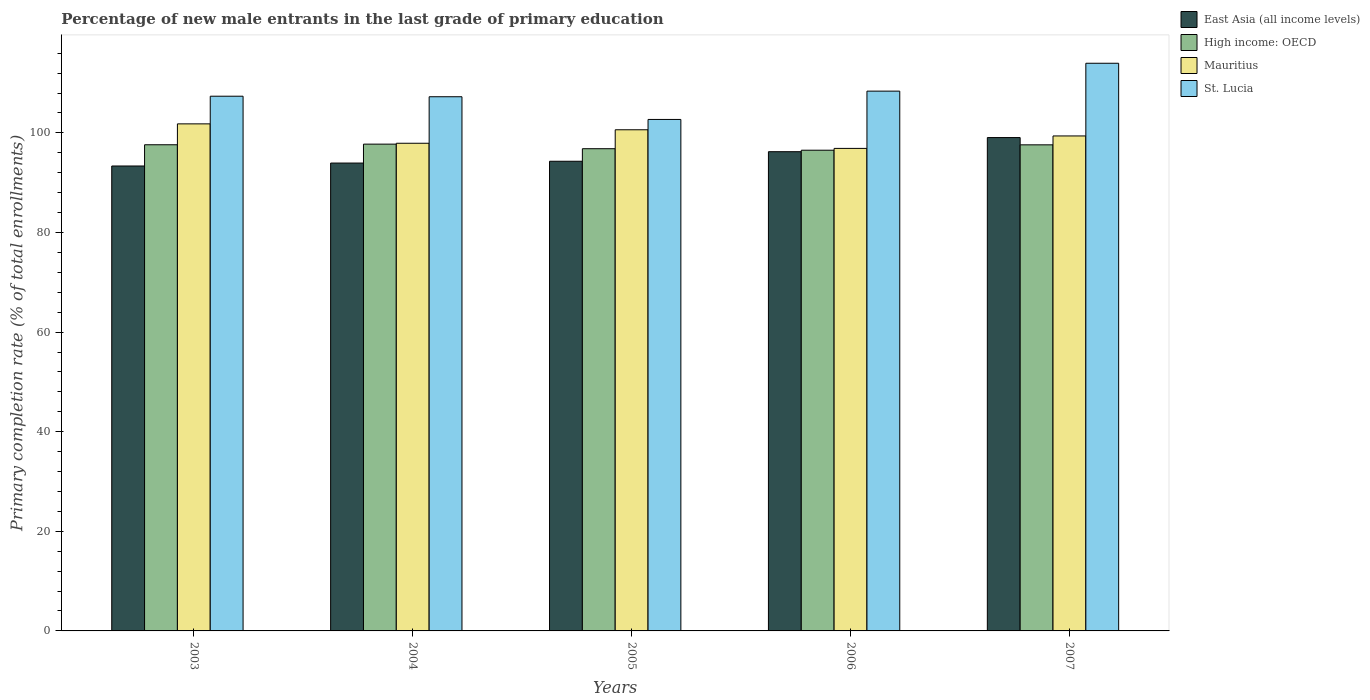How many different coloured bars are there?
Offer a terse response. 4. Are the number of bars per tick equal to the number of legend labels?
Make the answer very short. Yes. How many bars are there on the 5th tick from the left?
Provide a succinct answer. 4. What is the percentage of new male entrants in High income: OECD in 2006?
Your response must be concise. 96.52. Across all years, what is the maximum percentage of new male entrants in St. Lucia?
Give a very brief answer. 113.98. Across all years, what is the minimum percentage of new male entrants in East Asia (all income levels)?
Provide a succinct answer. 93.35. In which year was the percentage of new male entrants in St. Lucia minimum?
Keep it short and to the point. 2005. What is the total percentage of new male entrants in Mauritius in the graph?
Keep it short and to the point. 496.62. What is the difference between the percentage of new male entrants in Mauritius in 2003 and that in 2006?
Offer a terse response. 4.93. What is the difference between the percentage of new male entrants in Mauritius in 2006 and the percentage of new male entrants in High income: OECD in 2004?
Your answer should be very brief. -0.85. What is the average percentage of new male entrants in East Asia (all income levels) per year?
Give a very brief answer. 95.37. In the year 2007, what is the difference between the percentage of new male entrants in Mauritius and percentage of new male entrants in St. Lucia?
Your answer should be compact. -14.59. In how many years, is the percentage of new male entrants in Mauritius greater than 108 %?
Keep it short and to the point. 0. What is the ratio of the percentage of new male entrants in Mauritius in 2005 to that in 2007?
Ensure brevity in your answer.  1.01. Is the difference between the percentage of new male entrants in Mauritius in 2003 and 2007 greater than the difference between the percentage of new male entrants in St. Lucia in 2003 and 2007?
Your response must be concise. Yes. What is the difference between the highest and the second highest percentage of new male entrants in Mauritius?
Ensure brevity in your answer.  1.19. What is the difference between the highest and the lowest percentage of new male entrants in Mauritius?
Provide a succinct answer. 4.93. What does the 3rd bar from the left in 2004 represents?
Make the answer very short. Mauritius. What does the 1st bar from the right in 2003 represents?
Your answer should be compact. St. Lucia. Are all the bars in the graph horizontal?
Ensure brevity in your answer.  No. How many years are there in the graph?
Your response must be concise. 5. What is the difference between two consecutive major ticks on the Y-axis?
Provide a succinct answer. 20. Does the graph contain any zero values?
Give a very brief answer. No. Does the graph contain grids?
Your answer should be very brief. No. How many legend labels are there?
Provide a short and direct response. 4. What is the title of the graph?
Make the answer very short. Percentage of new male entrants in the last grade of primary education. Does "Canada" appear as one of the legend labels in the graph?
Offer a very short reply. No. What is the label or title of the Y-axis?
Offer a very short reply. Primary completion rate (% of total enrollments). What is the Primary completion rate (% of total enrollments) in East Asia (all income levels) in 2003?
Give a very brief answer. 93.35. What is the Primary completion rate (% of total enrollments) of High income: OECD in 2003?
Offer a terse response. 97.62. What is the Primary completion rate (% of total enrollments) in Mauritius in 2003?
Your answer should be very brief. 101.81. What is the Primary completion rate (% of total enrollments) in St. Lucia in 2003?
Make the answer very short. 107.36. What is the Primary completion rate (% of total enrollments) in East Asia (all income levels) in 2004?
Provide a short and direct response. 93.94. What is the Primary completion rate (% of total enrollments) of High income: OECD in 2004?
Provide a short and direct response. 97.74. What is the Primary completion rate (% of total enrollments) in Mauritius in 2004?
Keep it short and to the point. 97.92. What is the Primary completion rate (% of total enrollments) of St. Lucia in 2004?
Keep it short and to the point. 107.26. What is the Primary completion rate (% of total enrollments) of East Asia (all income levels) in 2005?
Provide a succinct answer. 94.3. What is the Primary completion rate (% of total enrollments) of High income: OECD in 2005?
Offer a terse response. 96.82. What is the Primary completion rate (% of total enrollments) in Mauritius in 2005?
Your answer should be compact. 100.62. What is the Primary completion rate (% of total enrollments) in St. Lucia in 2005?
Make the answer very short. 102.7. What is the Primary completion rate (% of total enrollments) of East Asia (all income levels) in 2006?
Your answer should be very brief. 96.22. What is the Primary completion rate (% of total enrollments) of High income: OECD in 2006?
Offer a very short reply. 96.52. What is the Primary completion rate (% of total enrollments) of Mauritius in 2006?
Offer a terse response. 96.88. What is the Primary completion rate (% of total enrollments) in St. Lucia in 2006?
Offer a very short reply. 108.38. What is the Primary completion rate (% of total enrollments) of East Asia (all income levels) in 2007?
Your response must be concise. 99.06. What is the Primary completion rate (% of total enrollments) in High income: OECD in 2007?
Provide a succinct answer. 97.6. What is the Primary completion rate (% of total enrollments) of Mauritius in 2007?
Your answer should be compact. 99.39. What is the Primary completion rate (% of total enrollments) of St. Lucia in 2007?
Give a very brief answer. 113.98. Across all years, what is the maximum Primary completion rate (% of total enrollments) in East Asia (all income levels)?
Your response must be concise. 99.06. Across all years, what is the maximum Primary completion rate (% of total enrollments) in High income: OECD?
Provide a succinct answer. 97.74. Across all years, what is the maximum Primary completion rate (% of total enrollments) of Mauritius?
Offer a very short reply. 101.81. Across all years, what is the maximum Primary completion rate (% of total enrollments) of St. Lucia?
Make the answer very short. 113.98. Across all years, what is the minimum Primary completion rate (% of total enrollments) in East Asia (all income levels)?
Provide a short and direct response. 93.35. Across all years, what is the minimum Primary completion rate (% of total enrollments) in High income: OECD?
Make the answer very short. 96.52. Across all years, what is the minimum Primary completion rate (% of total enrollments) in Mauritius?
Provide a short and direct response. 96.88. Across all years, what is the minimum Primary completion rate (% of total enrollments) in St. Lucia?
Give a very brief answer. 102.7. What is the total Primary completion rate (% of total enrollments) in East Asia (all income levels) in the graph?
Give a very brief answer. 476.87. What is the total Primary completion rate (% of total enrollments) in High income: OECD in the graph?
Offer a terse response. 486.3. What is the total Primary completion rate (% of total enrollments) in Mauritius in the graph?
Provide a succinct answer. 496.62. What is the total Primary completion rate (% of total enrollments) in St. Lucia in the graph?
Provide a succinct answer. 539.68. What is the difference between the Primary completion rate (% of total enrollments) of East Asia (all income levels) in 2003 and that in 2004?
Your answer should be very brief. -0.59. What is the difference between the Primary completion rate (% of total enrollments) in High income: OECD in 2003 and that in 2004?
Your response must be concise. -0.12. What is the difference between the Primary completion rate (% of total enrollments) of Mauritius in 2003 and that in 2004?
Provide a short and direct response. 3.89. What is the difference between the Primary completion rate (% of total enrollments) in St. Lucia in 2003 and that in 2004?
Provide a short and direct response. 0.11. What is the difference between the Primary completion rate (% of total enrollments) in East Asia (all income levels) in 2003 and that in 2005?
Offer a terse response. -0.95. What is the difference between the Primary completion rate (% of total enrollments) of High income: OECD in 2003 and that in 2005?
Offer a terse response. 0.79. What is the difference between the Primary completion rate (% of total enrollments) in Mauritius in 2003 and that in 2005?
Provide a succinct answer. 1.19. What is the difference between the Primary completion rate (% of total enrollments) of St. Lucia in 2003 and that in 2005?
Keep it short and to the point. 4.66. What is the difference between the Primary completion rate (% of total enrollments) in East Asia (all income levels) in 2003 and that in 2006?
Keep it short and to the point. -2.87. What is the difference between the Primary completion rate (% of total enrollments) of High income: OECD in 2003 and that in 2006?
Offer a very short reply. 1.09. What is the difference between the Primary completion rate (% of total enrollments) of Mauritius in 2003 and that in 2006?
Provide a short and direct response. 4.93. What is the difference between the Primary completion rate (% of total enrollments) of St. Lucia in 2003 and that in 2006?
Offer a very short reply. -1.02. What is the difference between the Primary completion rate (% of total enrollments) in East Asia (all income levels) in 2003 and that in 2007?
Your answer should be compact. -5.71. What is the difference between the Primary completion rate (% of total enrollments) in High income: OECD in 2003 and that in 2007?
Offer a very short reply. 0.02. What is the difference between the Primary completion rate (% of total enrollments) in Mauritius in 2003 and that in 2007?
Your answer should be very brief. 2.42. What is the difference between the Primary completion rate (% of total enrollments) in St. Lucia in 2003 and that in 2007?
Keep it short and to the point. -6.62. What is the difference between the Primary completion rate (% of total enrollments) in East Asia (all income levels) in 2004 and that in 2005?
Give a very brief answer. -0.36. What is the difference between the Primary completion rate (% of total enrollments) of High income: OECD in 2004 and that in 2005?
Your answer should be very brief. 0.92. What is the difference between the Primary completion rate (% of total enrollments) of Mauritius in 2004 and that in 2005?
Offer a terse response. -2.71. What is the difference between the Primary completion rate (% of total enrollments) in St. Lucia in 2004 and that in 2005?
Keep it short and to the point. 4.56. What is the difference between the Primary completion rate (% of total enrollments) of East Asia (all income levels) in 2004 and that in 2006?
Provide a succinct answer. -2.28. What is the difference between the Primary completion rate (% of total enrollments) in High income: OECD in 2004 and that in 2006?
Your answer should be compact. 1.22. What is the difference between the Primary completion rate (% of total enrollments) in Mauritius in 2004 and that in 2006?
Provide a short and direct response. 1.03. What is the difference between the Primary completion rate (% of total enrollments) of St. Lucia in 2004 and that in 2006?
Keep it short and to the point. -1.12. What is the difference between the Primary completion rate (% of total enrollments) of East Asia (all income levels) in 2004 and that in 2007?
Your answer should be compact. -5.12. What is the difference between the Primary completion rate (% of total enrollments) in High income: OECD in 2004 and that in 2007?
Offer a very short reply. 0.14. What is the difference between the Primary completion rate (% of total enrollments) in Mauritius in 2004 and that in 2007?
Offer a very short reply. -1.47. What is the difference between the Primary completion rate (% of total enrollments) in St. Lucia in 2004 and that in 2007?
Ensure brevity in your answer.  -6.72. What is the difference between the Primary completion rate (% of total enrollments) in East Asia (all income levels) in 2005 and that in 2006?
Your answer should be very brief. -1.92. What is the difference between the Primary completion rate (% of total enrollments) in High income: OECD in 2005 and that in 2006?
Offer a very short reply. 0.3. What is the difference between the Primary completion rate (% of total enrollments) in Mauritius in 2005 and that in 2006?
Your answer should be compact. 3.74. What is the difference between the Primary completion rate (% of total enrollments) in St. Lucia in 2005 and that in 2006?
Your response must be concise. -5.68. What is the difference between the Primary completion rate (% of total enrollments) of East Asia (all income levels) in 2005 and that in 2007?
Your answer should be very brief. -4.76. What is the difference between the Primary completion rate (% of total enrollments) in High income: OECD in 2005 and that in 2007?
Your answer should be very brief. -0.78. What is the difference between the Primary completion rate (% of total enrollments) of Mauritius in 2005 and that in 2007?
Provide a short and direct response. 1.24. What is the difference between the Primary completion rate (% of total enrollments) in St. Lucia in 2005 and that in 2007?
Provide a short and direct response. -11.28. What is the difference between the Primary completion rate (% of total enrollments) of East Asia (all income levels) in 2006 and that in 2007?
Ensure brevity in your answer.  -2.84. What is the difference between the Primary completion rate (% of total enrollments) in High income: OECD in 2006 and that in 2007?
Make the answer very short. -1.08. What is the difference between the Primary completion rate (% of total enrollments) in Mauritius in 2006 and that in 2007?
Your answer should be very brief. -2.5. What is the difference between the Primary completion rate (% of total enrollments) of St. Lucia in 2006 and that in 2007?
Make the answer very short. -5.6. What is the difference between the Primary completion rate (% of total enrollments) of East Asia (all income levels) in 2003 and the Primary completion rate (% of total enrollments) of High income: OECD in 2004?
Your answer should be compact. -4.39. What is the difference between the Primary completion rate (% of total enrollments) of East Asia (all income levels) in 2003 and the Primary completion rate (% of total enrollments) of Mauritius in 2004?
Offer a very short reply. -4.56. What is the difference between the Primary completion rate (% of total enrollments) in East Asia (all income levels) in 2003 and the Primary completion rate (% of total enrollments) in St. Lucia in 2004?
Your response must be concise. -13.91. What is the difference between the Primary completion rate (% of total enrollments) of High income: OECD in 2003 and the Primary completion rate (% of total enrollments) of Mauritius in 2004?
Your answer should be compact. -0.3. What is the difference between the Primary completion rate (% of total enrollments) in High income: OECD in 2003 and the Primary completion rate (% of total enrollments) in St. Lucia in 2004?
Provide a short and direct response. -9.64. What is the difference between the Primary completion rate (% of total enrollments) in Mauritius in 2003 and the Primary completion rate (% of total enrollments) in St. Lucia in 2004?
Offer a terse response. -5.45. What is the difference between the Primary completion rate (% of total enrollments) in East Asia (all income levels) in 2003 and the Primary completion rate (% of total enrollments) in High income: OECD in 2005?
Give a very brief answer. -3.47. What is the difference between the Primary completion rate (% of total enrollments) of East Asia (all income levels) in 2003 and the Primary completion rate (% of total enrollments) of Mauritius in 2005?
Offer a terse response. -7.27. What is the difference between the Primary completion rate (% of total enrollments) of East Asia (all income levels) in 2003 and the Primary completion rate (% of total enrollments) of St. Lucia in 2005?
Offer a terse response. -9.35. What is the difference between the Primary completion rate (% of total enrollments) in High income: OECD in 2003 and the Primary completion rate (% of total enrollments) in Mauritius in 2005?
Keep it short and to the point. -3.01. What is the difference between the Primary completion rate (% of total enrollments) in High income: OECD in 2003 and the Primary completion rate (% of total enrollments) in St. Lucia in 2005?
Your response must be concise. -5.08. What is the difference between the Primary completion rate (% of total enrollments) in Mauritius in 2003 and the Primary completion rate (% of total enrollments) in St. Lucia in 2005?
Offer a terse response. -0.89. What is the difference between the Primary completion rate (% of total enrollments) of East Asia (all income levels) in 2003 and the Primary completion rate (% of total enrollments) of High income: OECD in 2006?
Your response must be concise. -3.17. What is the difference between the Primary completion rate (% of total enrollments) in East Asia (all income levels) in 2003 and the Primary completion rate (% of total enrollments) in Mauritius in 2006?
Provide a short and direct response. -3.53. What is the difference between the Primary completion rate (% of total enrollments) in East Asia (all income levels) in 2003 and the Primary completion rate (% of total enrollments) in St. Lucia in 2006?
Your answer should be very brief. -15.03. What is the difference between the Primary completion rate (% of total enrollments) in High income: OECD in 2003 and the Primary completion rate (% of total enrollments) in Mauritius in 2006?
Provide a short and direct response. 0.73. What is the difference between the Primary completion rate (% of total enrollments) in High income: OECD in 2003 and the Primary completion rate (% of total enrollments) in St. Lucia in 2006?
Keep it short and to the point. -10.77. What is the difference between the Primary completion rate (% of total enrollments) in Mauritius in 2003 and the Primary completion rate (% of total enrollments) in St. Lucia in 2006?
Ensure brevity in your answer.  -6.57. What is the difference between the Primary completion rate (% of total enrollments) of East Asia (all income levels) in 2003 and the Primary completion rate (% of total enrollments) of High income: OECD in 2007?
Your answer should be compact. -4.25. What is the difference between the Primary completion rate (% of total enrollments) of East Asia (all income levels) in 2003 and the Primary completion rate (% of total enrollments) of Mauritius in 2007?
Your response must be concise. -6.03. What is the difference between the Primary completion rate (% of total enrollments) of East Asia (all income levels) in 2003 and the Primary completion rate (% of total enrollments) of St. Lucia in 2007?
Your answer should be very brief. -20.63. What is the difference between the Primary completion rate (% of total enrollments) of High income: OECD in 2003 and the Primary completion rate (% of total enrollments) of Mauritius in 2007?
Provide a short and direct response. -1.77. What is the difference between the Primary completion rate (% of total enrollments) in High income: OECD in 2003 and the Primary completion rate (% of total enrollments) in St. Lucia in 2007?
Provide a succinct answer. -16.36. What is the difference between the Primary completion rate (% of total enrollments) in Mauritius in 2003 and the Primary completion rate (% of total enrollments) in St. Lucia in 2007?
Your answer should be compact. -12.17. What is the difference between the Primary completion rate (% of total enrollments) of East Asia (all income levels) in 2004 and the Primary completion rate (% of total enrollments) of High income: OECD in 2005?
Give a very brief answer. -2.88. What is the difference between the Primary completion rate (% of total enrollments) of East Asia (all income levels) in 2004 and the Primary completion rate (% of total enrollments) of Mauritius in 2005?
Give a very brief answer. -6.68. What is the difference between the Primary completion rate (% of total enrollments) in East Asia (all income levels) in 2004 and the Primary completion rate (% of total enrollments) in St. Lucia in 2005?
Keep it short and to the point. -8.76. What is the difference between the Primary completion rate (% of total enrollments) of High income: OECD in 2004 and the Primary completion rate (% of total enrollments) of Mauritius in 2005?
Your answer should be very brief. -2.88. What is the difference between the Primary completion rate (% of total enrollments) of High income: OECD in 2004 and the Primary completion rate (% of total enrollments) of St. Lucia in 2005?
Your answer should be very brief. -4.96. What is the difference between the Primary completion rate (% of total enrollments) in Mauritius in 2004 and the Primary completion rate (% of total enrollments) in St. Lucia in 2005?
Give a very brief answer. -4.78. What is the difference between the Primary completion rate (% of total enrollments) of East Asia (all income levels) in 2004 and the Primary completion rate (% of total enrollments) of High income: OECD in 2006?
Offer a terse response. -2.58. What is the difference between the Primary completion rate (% of total enrollments) in East Asia (all income levels) in 2004 and the Primary completion rate (% of total enrollments) in Mauritius in 2006?
Your response must be concise. -2.94. What is the difference between the Primary completion rate (% of total enrollments) in East Asia (all income levels) in 2004 and the Primary completion rate (% of total enrollments) in St. Lucia in 2006?
Offer a terse response. -14.44. What is the difference between the Primary completion rate (% of total enrollments) in High income: OECD in 2004 and the Primary completion rate (% of total enrollments) in Mauritius in 2006?
Give a very brief answer. 0.85. What is the difference between the Primary completion rate (% of total enrollments) of High income: OECD in 2004 and the Primary completion rate (% of total enrollments) of St. Lucia in 2006?
Offer a terse response. -10.64. What is the difference between the Primary completion rate (% of total enrollments) in Mauritius in 2004 and the Primary completion rate (% of total enrollments) in St. Lucia in 2006?
Keep it short and to the point. -10.47. What is the difference between the Primary completion rate (% of total enrollments) in East Asia (all income levels) in 2004 and the Primary completion rate (% of total enrollments) in High income: OECD in 2007?
Offer a terse response. -3.66. What is the difference between the Primary completion rate (% of total enrollments) in East Asia (all income levels) in 2004 and the Primary completion rate (% of total enrollments) in Mauritius in 2007?
Your answer should be compact. -5.45. What is the difference between the Primary completion rate (% of total enrollments) of East Asia (all income levels) in 2004 and the Primary completion rate (% of total enrollments) of St. Lucia in 2007?
Your answer should be compact. -20.04. What is the difference between the Primary completion rate (% of total enrollments) of High income: OECD in 2004 and the Primary completion rate (% of total enrollments) of Mauritius in 2007?
Your answer should be compact. -1.65. What is the difference between the Primary completion rate (% of total enrollments) in High income: OECD in 2004 and the Primary completion rate (% of total enrollments) in St. Lucia in 2007?
Offer a terse response. -16.24. What is the difference between the Primary completion rate (% of total enrollments) in Mauritius in 2004 and the Primary completion rate (% of total enrollments) in St. Lucia in 2007?
Ensure brevity in your answer.  -16.06. What is the difference between the Primary completion rate (% of total enrollments) in East Asia (all income levels) in 2005 and the Primary completion rate (% of total enrollments) in High income: OECD in 2006?
Provide a succinct answer. -2.22. What is the difference between the Primary completion rate (% of total enrollments) in East Asia (all income levels) in 2005 and the Primary completion rate (% of total enrollments) in Mauritius in 2006?
Provide a short and direct response. -2.58. What is the difference between the Primary completion rate (% of total enrollments) of East Asia (all income levels) in 2005 and the Primary completion rate (% of total enrollments) of St. Lucia in 2006?
Provide a short and direct response. -14.08. What is the difference between the Primary completion rate (% of total enrollments) of High income: OECD in 2005 and the Primary completion rate (% of total enrollments) of Mauritius in 2006?
Your answer should be very brief. -0.06. What is the difference between the Primary completion rate (% of total enrollments) of High income: OECD in 2005 and the Primary completion rate (% of total enrollments) of St. Lucia in 2006?
Your response must be concise. -11.56. What is the difference between the Primary completion rate (% of total enrollments) of Mauritius in 2005 and the Primary completion rate (% of total enrollments) of St. Lucia in 2006?
Give a very brief answer. -7.76. What is the difference between the Primary completion rate (% of total enrollments) of East Asia (all income levels) in 2005 and the Primary completion rate (% of total enrollments) of High income: OECD in 2007?
Offer a terse response. -3.3. What is the difference between the Primary completion rate (% of total enrollments) of East Asia (all income levels) in 2005 and the Primary completion rate (% of total enrollments) of Mauritius in 2007?
Your response must be concise. -5.08. What is the difference between the Primary completion rate (% of total enrollments) in East Asia (all income levels) in 2005 and the Primary completion rate (% of total enrollments) in St. Lucia in 2007?
Give a very brief answer. -19.68. What is the difference between the Primary completion rate (% of total enrollments) in High income: OECD in 2005 and the Primary completion rate (% of total enrollments) in Mauritius in 2007?
Your answer should be very brief. -2.56. What is the difference between the Primary completion rate (% of total enrollments) of High income: OECD in 2005 and the Primary completion rate (% of total enrollments) of St. Lucia in 2007?
Keep it short and to the point. -17.16. What is the difference between the Primary completion rate (% of total enrollments) in Mauritius in 2005 and the Primary completion rate (% of total enrollments) in St. Lucia in 2007?
Give a very brief answer. -13.36. What is the difference between the Primary completion rate (% of total enrollments) in East Asia (all income levels) in 2006 and the Primary completion rate (% of total enrollments) in High income: OECD in 2007?
Your answer should be compact. -1.38. What is the difference between the Primary completion rate (% of total enrollments) of East Asia (all income levels) in 2006 and the Primary completion rate (% of total enrollments) of Mauritius in 2007?
Your answer should be compact. -3.16. What is the difference between the Primary completion rate (% of total enrollments) in East Asia (all income levels) in 2006 and the Primary completion rate (% of total enrollments) in St. Lucia in 2007?
Make the answer very short. -17.76. What is the difference between the Primary completion rate (% of total enrollments) in High income: OECD in 2006 and the Primary completion rate (% of total enrollments) in Mauritius in 2007?
Keep it short and to the point. -2.86. What is the difference between the Primary completion rate (% of total enrollments) of High income: OECD in 2006 and the Primary completion rate (% of total enrollments) of St. Lucia in 2007?
Your answer should be compact. -17.46. What is the difference between the Primary completion rate (% of total enrollments) in Mauritius in 2006 and the Primary completion rate (% of total enrollments) in St. Lucia in 2007?
Give a very brief answer. -17.09. What is the average Primary completion rate (% of total enrollments) of East Asia (all income levels) per year?
Keep it short and to the point. 95.37. What is the average Primary completion rate (% of total enrollments) of High income: OECD per year?
Make the answer very short. 97.26. What is the average Primary completion rate (% of total enrollments) in Mauritius per year?
Offer a terse response. 99.32. What is the average Primary completion rate (% of total enrollments) of St. Lucia per year?
Your answer should be very brief. 107.94. In the year 2003, what is the difference between the Primary completion rate (% of total enrollments) in East Asia (all income levels) and Primary completion rate (% of total enrollments) in High income: OECD?
Your response must be concise. -4.26. In the year 2003, what is the difference between the Primary completion rate (% of total enrollments) of East Asia (all income levels) and Primary completion rate (% of total enrollments) of Mauritius?
Provide a short and direct response. -8.46. In the year 2003, what is the difference between the Primary completion rate (% of total enrollments) in East Asia (all income levels) and Primary completion rate (% of total enrollments) in St. Lucia?
Give a very brief answer. -14.01. In the year 2003, what is the difference between the Primary completion rate (% of total enrollments) of High income: OECD and Primary completion rate (% of total enrollments) of Mauritius?
Your answer should be compact. -4.19. In the year 2003, what is the difference between the Primary completion rate (% of total enrollments) of High income: OECD and Primary completion rate (% of total enrollments) of St. Lucia?
Your response must be concise. -9.75. In the year 2003, what is the difference between the Primary completion rate (% of total enrollments) in Mauritius and Primary completion rate (% of total enrollments) in St. Lucia?
Provide a short and direct response. -5.55. In the year 2004, what is the difference between the Primary completion rate (% of total enrollments) of East Asia (all income levels) and Primary completion rate (% of total enrollments) of High income: OECD?
Offer a terse response. -3.8. In the year 2004, what is the difference between the Primary completion rate (% of total enrollments) of East Asia (all income levels) and Primary completion rate (% of total enrollments) of Mauritius?
Keep it short and to the point. -3.97. In the year 2004, what is the difference between the Primary completion rate (% of total enrollments) in East Asia (all income levels) and Primary completion rate (% of total enrollments) in St. Lucia?
Your answer should be very brief. -13.32. In the year 2004, what is the difference between the Primary completion rate (% of total enrollments) of High income: OECD and Primary completion rate (% of total enrollments) of Mauritius?
Keep it short and to the point. -0.18. In the year 2004, what is the difference between the Primary completion rate (% of total enrollments) of High income: OECD and Primary completion rate (% of total enrollments) of St. Lucia?
Your answer should be very brief. -9.52. In the year 2004, what is the difference between the Primary completion rate (% of total enrollments) of Mauritius and Primary completion rate (% of total enrollments) of St. Lucia?
Keep it short and to the point. -9.34. In the year 2005, what is the difference between the Primary completion rate (% of total enrollments) of East Asia (all income levels) and Primary completion rate (% of total enrollments) of High income: OECD?
Provide a short and direct response. -2.52. In the year 2005, what is the difference between the Primary completion rate (% of total enrollments) in East Asia (all income levels) and Primary completion rate (% of total enrollments) in Mauritius?
Offer a terse response. -6.32. In the year 2005, what is the difference between the Primary completion rate (% of total enrollments) in East Asia (all income levels) and Primary completion rate (% of total enrollments) in St. Lucia?
Keep it short and to the point. -8.4. In the year 2005, what is the difference between the Primary completion rate (% of total enrollments) in High income: OECD and Primary completion rate (% of total enrollments) in Mauritius?
Your answer should be compact. -3.8. In the year 2005, what is the difference between the Primary completion rate (% of total enrollments) in High income: OECD and Primary completion rate (% of total enrollments) in St. Lucia?
Ensure brevity in your answer.  -5.88. In the year 2005, what is the difference between the Primary completion rate (% of total enrollments) of Mauritius and Primary completion rate (% of total enrollments) of St. Lucia?
Ensure brevity in your answer.  -2.08. In the year 2006, what is the difference between the Primary completion rate (% of total enrollments) of East Asia (all income levels) and Primary completion rate (% of total enrollments) of High income: OECD?
Your answer should be very brief. -0.3. In the year 2006, what is the difference between the Primary completion rate (% of total enrollments) of East Asia (all income levels) and Primary completion rate (% of total enrollments) of Mauritius?
Make the answer very short. -0.66. In the year 2006, what is the difference between the Primary completion rate (% of total enrollments) in East Asia (all income levels) and Primary completion rate (% of total enrollments) in St. Lucia?
Offer a very short reply. -12.16. In the year 2006, what is the difference between the Primary completion rate (% of total enrollments) in High income: OECD and Primary completion rate (% of total enrollments) in Mauritius?
Keep it short and to the point. -0.36. In the year 2006, what is the difference between the Primary completion rate (% of total enrollments) in High income: OECD and Primary completion rate (% of total enrollments) in St. Lucia?
Keep it short and to the point. -11.86. In the year 2006, what is the difference between the Primary completion rate (% of total enrollments) in Mauritius and Primary completion rate (% of total enrollments) in St. Lucia?
Offer a very short reply. -11.5. In the year 2007, what is the difference between the Primary completion rate (% of total enrollments) of East Asia (all income levels) and Primary completion rate (% of total enrollments) of High income: OECD?
Offer a very short reply. 1.46. In the year 2007, what is the difference between the Primary completion rate (% of total enrollments) of East Asia (all income levels) and Primary completion rate (% of total enrollments) of Mauritius?
Offer a very short reply. -0.33. In the year 2007, what is the difference between the Primary completion rate (% of total enrollments) in East Asia (all income levels) and Primary completion rate (% of total enrollments) in St. Lucia?
Ensure brevity in your answer.  -14.92. In the year 2007, what is the difference between the Primary completion rate (% of total enrollments) in High income: OECD and Primary completion rate (% of total enrollments) in Mauritius?
Your response must be concise. -1.79. In the year 2007, what is the difference between the Primary completion rate (% of total enrollments) of High income: OECD and Primary completion rate (% of total enrollments) of St. Lucia?
Keep it short and to the point. -16.38. In the year 2007, what is the difference between the Primary completion rate (% of total enrollments) of Mauritius and Primary completion rate (% of total enrollments) of St. Lucia?
Your answer should be very brief. -14.59. What is the ratio of the Primary completion rate (% of total enrollments) in East Asia (all income levels) in 2003 to that in 2004?
Ensure brevity in your answer.  0.99. What is the ratio of the Primary completion rate (% of total enrollments) in Mauritius in 2003 to that in 2004?
Offer a terse response. 1.04. What is the ratio of the Primary completion rate (% of total enrollments) in St. Lucia in 2003 to that in 2004?
Provide a short and direct response. 1. What is the ratio of the Primary completion rate (% of total enrollments) in East Asia (all income levels) in 2003 to that in 2005?
Offer a terse response. 0.99. What is the ratio of the Primary completion rate (% of total enrollments) of High income: OECD in 2003 to that in 2005?
Make the answer very short. 1.01. What is the ratio of the Primary completion rate (% of total enrollments) of Mauritius in 2003 to that in 2005?
Provide a succinct answer. 1.01. What is the ratio of the Primary completion rate (% of total enrollments) of St. Lucia in 2003 to that in 2005?
Make the answer very short. 1.05. What is the ratio of the Primary completion rate (% of total enrollments) of East Asia (all income levels) in 2003 to that in 2006?
Provide a short and direct response. 0.97. What is the ratio of the Primary completion rate (% of total enrollments) of High income: OECD in 2003 to that in 2006?
Make the answer very short. 1.01. What is the ratio of the Primary completion rate (% of total enrollments) in Mauritius in 2003 to that in 2006?
Keep it short and to the point. 1.05. What is the ratio of the Primary completion rate (% of total enrollments) in St. Lucia in 2003 to that in 2006?
Offer a very short reply. 0.99. What is the ratio of the Primary completion rate (% of total enrollments) of East Asia (all income levels) in 2003 to that in 2007?
Offer a very short reply. 0.94. What is the ratio of the Primary completion rate (% of total enrollments) of High income: OECD in 2003 to that in 2007?
Offer a very short reply. 1. What is the ratio of the Primary completion rate (% of total enrollments) of Mauritius in 2003 to that in 2007?
Your answer should be compact. 1.02. What is the ratio of the Primary completion rate (% of total enrollments) of St. Lucia in 2003 to that in 2007?
Provide a short and direct response. 0.94. What is the ratio of the Primary completion rate (% of total enrollments) of East Asia (all income levels) in 2004 to that in 2005?
Give a very brief answer. 1. What is the ratio of the Primary completion rate (% of total enrollments) of High income: OECD in 2004 to that in 2005?
Ensure brevity in your answer.  1.01. What is the ratio of the Primary completion rate (% of total enrollments) of Mauritius in 2004 to that in 2005?
Make the answer very short. 0.97. What is the ratio of the Primary completion rate (% of total enrollments) of St. Lucia in 2004 to that in 2005?
Offer a terse response. 1.04. What is the ratio of the Primary completion rate (% of total enrollments) of East Asia (all income levels) in 2004 to that in 2006?
Keep it short and to the point. 0.98. What is the ratio of the Primary completion rate (% of total enrollments) in High income: OECD in 2004 to that in 2006?
Ensure brevity in your answer.  1.01. What is the ratio of the Primary completion rate (% of total enrollments) in Mauritius in 2004 to that in 2006?
Your answer should be very brief. 1.01. What is the ratio of the Primary completion rate (% of total enrollments) in East Asia (all income levels) in 2004 to that in 2007?
Offer a terse response. 0.95. What is the ratio of the Primary completion rate (% of total enrollments) of High income: OECD in 2004 to that in 2007?
Keep it short and to the point. 1. What is the ratio of the Primary completion rate (% of total enrollments) of Mauritius in 2004 to that in 2007?
Keep it short and to the point. 0.99. What is the ratio of the Primary completion rate (% of total enrollments) in St. Lucia in 2004 to that in 2007?
Give a very brief answer. 0.94. What is the ratio of the Primary completion rate (% of total enrollments) of Mauritius in 2005 to that in 2006?
Your answer should be compact. 1.04. What is the ratio of the Primary completion rate (% of total enrollments) of St. Lucia in 2005 to that in 2006?
Keep it short and to the point. 0.95. What is the ratio of the Primary completion rate (% of total enrollments) in East Asia (all income levels) in 2005 to that in 2007?
Ensure brevity in your answer.  0.95. What is the ratio of the Primary completion rate (% of total enrollments) of High income: OECD in 2005 to that in 2007?
Give a very brief answer. 0.99. What is the ratio of the Primary completion rate (% of total enrollments) of Mauritius in 2005 to that in 2007?
Your response must be concise. 1.01. What is the ratio of the Primary completion rate (% of total enrollments) of St. Lucia in 2005 to that in 2007?
Offer a terse response. 0.9. What is the ratio of the Primary completion rate (% of total enrollments) of East Asia (all income levels) in 2006 to that in 2007?
Make the answer very short. 0.97. What is the ratio of the Primary completion rate (% of total enrollments) of High income: OECD in 2006 to that in 2007?
Offer a terse response. 0.99. What is the ratio of the Primary completion rate (% of total enrollments) in Mauritius in 2006 to that in 2007?
Give a very brief answer. 0.97. What is the ratio of the Primary completion rate (% of total enrollments) in St. Lucia in 2006 to that in 2007?
Your answer should be compact. 0.95. What is the difference between the highest and the second highest Primary completion rate (% of total enrollments) of East Asia (all income levels)?
Your response must be concise. 2.84. What is the difference between the highest and the second highest Primary completion rate (% of total enrollments) in High income: OECD?
Offer a very short reply. 0.12. What is the difference between the highest and the second highest Primary completion rate (% of total enrollments) in Mauritius?
Ensure brevity in your answer.  1.19. What is the difference between the highest and the second highest Primary completion rate (% of total enrollments) in St. Lucia?
Provide a succinct answer. 5.6. What is the difference between the highest and the lowest Primary completion rate (% of total enrollments) of East Asia (all income levels)?
Your response must be concise. 5.71. What is the difference between the highest and the lowest Primary completion rate (% of total enrollments) of High income: OECD?
Offer a terse response. 1.22. What is the difference between the highest and the lowest Primary completion rate (% of total enrollments) in Mauritius?
Make the answer very short. 4.93. What is the difference between the highest and the lowest Primary completion rate (% of total enrollments) in St. Lucia?
Offer a terse response. 11.28. 